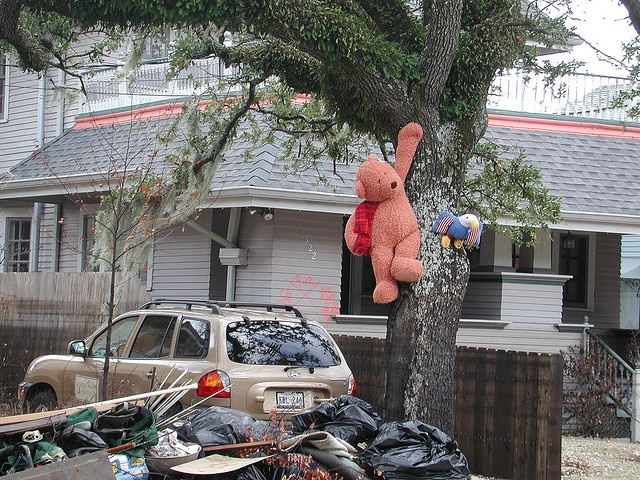Describe the objects in this image and their specific colors. I can see car in gray, darkgray, black, and lightgray tones, teddy bear in gray, brown, and salmon tones, and bird in gray, lightgray, darkgray, and maroon tones in this image. 